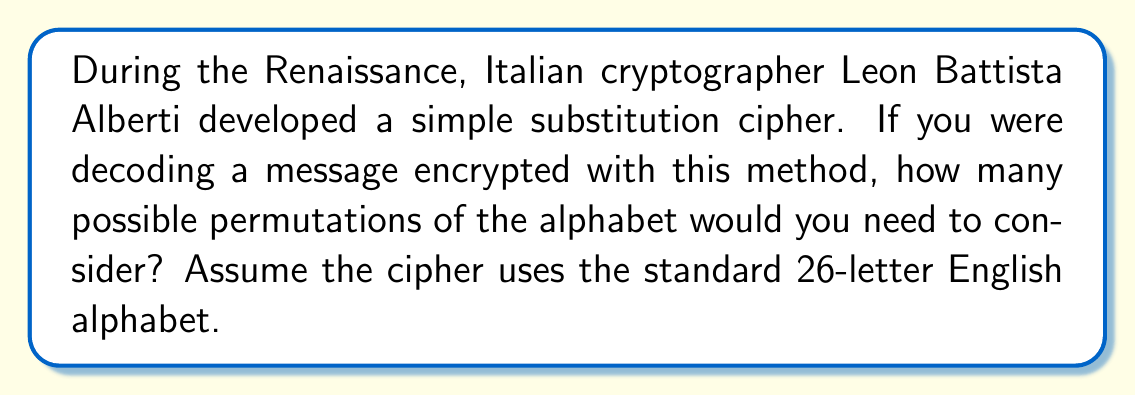Provide a solution to this math problem. To solve this problem, we need to understand the concept of permutations and apply it to the 26 letters of the English alphabet. Let's break it down step-by-step:

1. In a simple substitution cipher, each letter of the plaintext is replaced by a different letter of the alphabet. This means we are arranging all 26 letters in a different order.

2. The number of ways to arrange n distinct objects is given by the factorial of n, denoted as n!

3. In this case, n = 26 (the number of letters in the English alphabet)

4. Therefore, the number of possible permutations is 26!

5. Let's calculate this:

   $$26! = 26 \times 25 \times 24 \times 23 \times ... \times 3 \times 2 \times 1$$

6. This is a very large number. Using a calculator or computer, we can determine that:

   $$26! = 403,291,461,126,605,635,584,000,000$$

This means that if you were trying to crack the code by brute force, you would need to consider over 403 quintillion possible arrangements of the alphabet!

It's worth noting that in practice, cryptanalysts use frequency analysis and other techniques to narrow down the possibilities, as checking all permutations would be computationally infeasible.
Answer: $26! = 403,291,461,126,605,635,584,000,000$ 